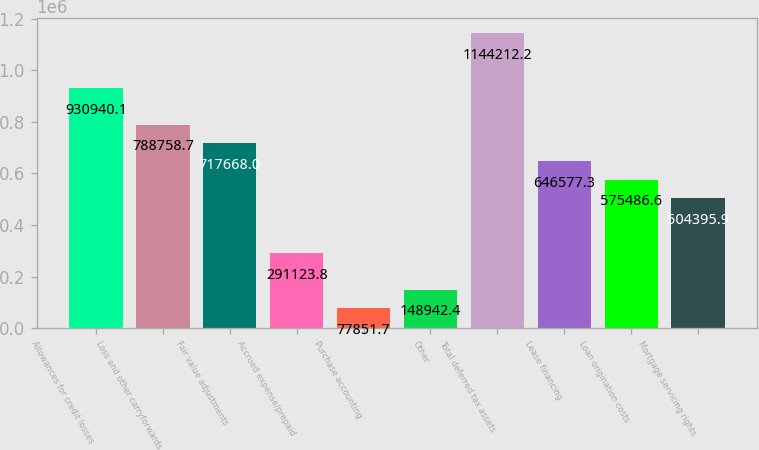Convert chart. <chart><loc_0><loc_0><loc_500><loc_500><bar_chart><fcel>Allowances for credit losses<fcel>Loss and other carryforwards<fcel>Fair value adjustments<fcel>Accrued expense/prepaid<fcel>Purchase accounting<fcel>Other<fcel>Total deferred tax assets<fcel>Lease financing<fcel>Loan origination costs<fcel>Mortgage servicing rights<nl><fcel>930940<fcel>788759<fcel>717668<fcel>291124<fcel>77851.7<fcel>148942<fcel>1.14421e+06<fcel>646577<fcel>575487<fcel>504396<nl></chart> 